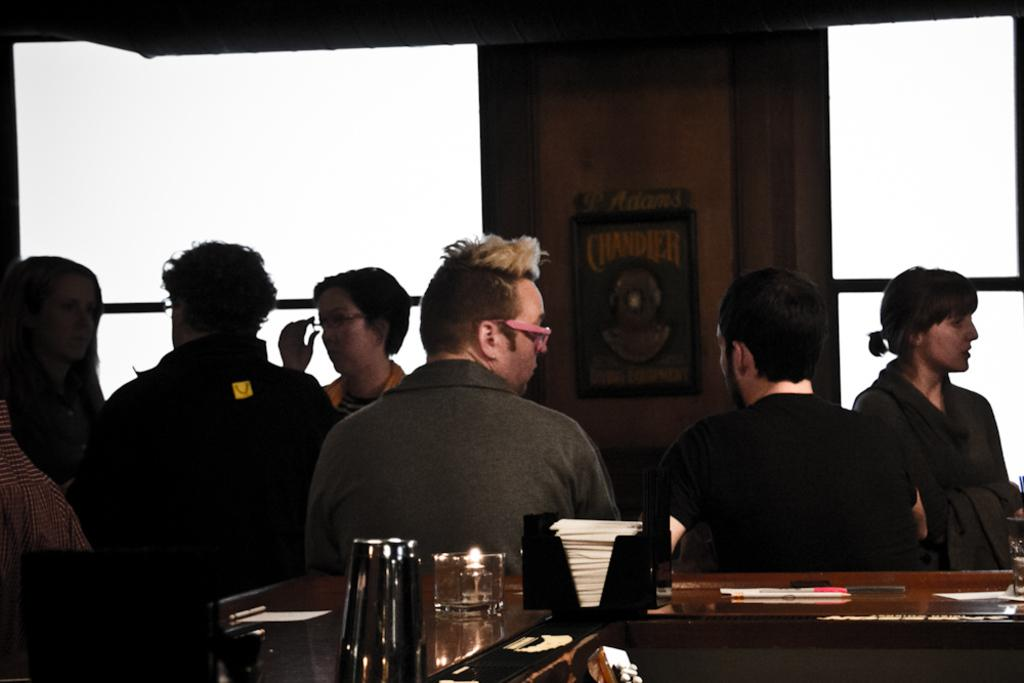Who or what can be seen in the image? There are people in the image. What is present on the table in the image? There are things on a table in the image. What can be seen in the background of the image? There is a wall in the background of the image. Can you describe any specific details about the wall in the background? There is a photo frame on the wall in the background of the image. What is the average income of the people in the image? There is no information about the income of the people in the image, so it cannot be determined. 